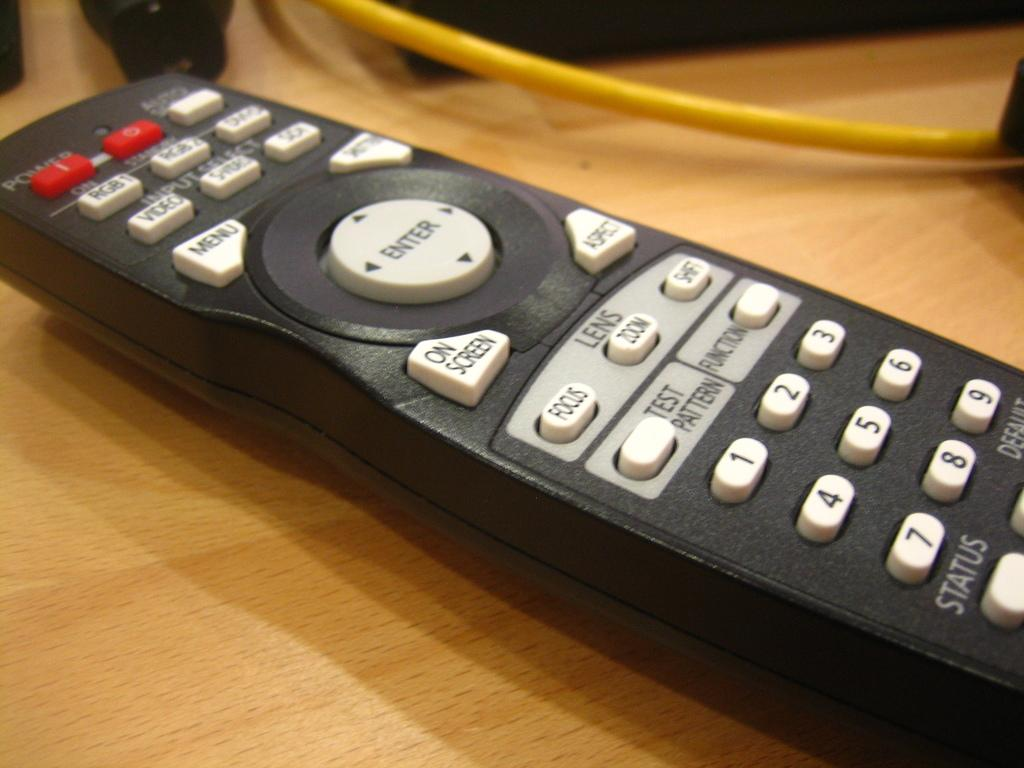<image>
Render a clear and concise summary of the photo. On top of a wooden surface is a black remote, with white buttons and the enter button in the center of the remote. 